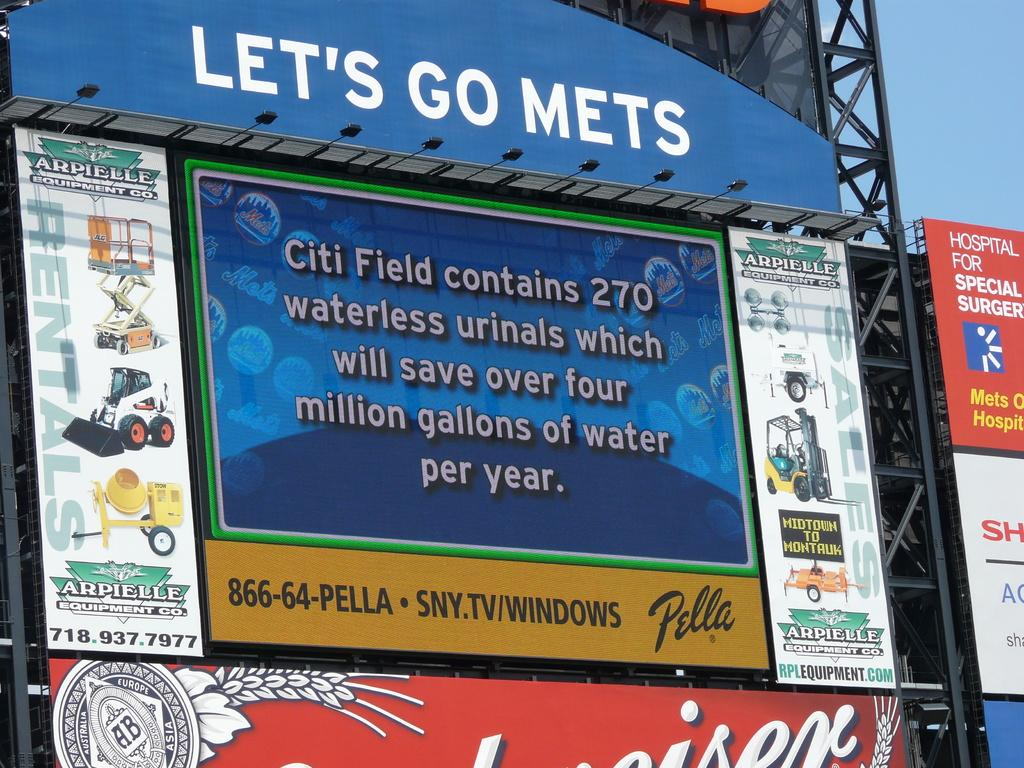What type of objects are present on the boards in the image? The boards have text and images in the image. What are the tall structures made of in the image? The tall structures are metal towers in the image. What is the color of the objects mentioned in the image? The objects are black colored in the image. What can be seen in the background of the image? The sky is visible in the image. What time of day is it in the image, and is there a yak present? The time of day cannot be determined from the image, and there is no yak present in the image. How is the hook used in the image? There is no hook present in the image. 